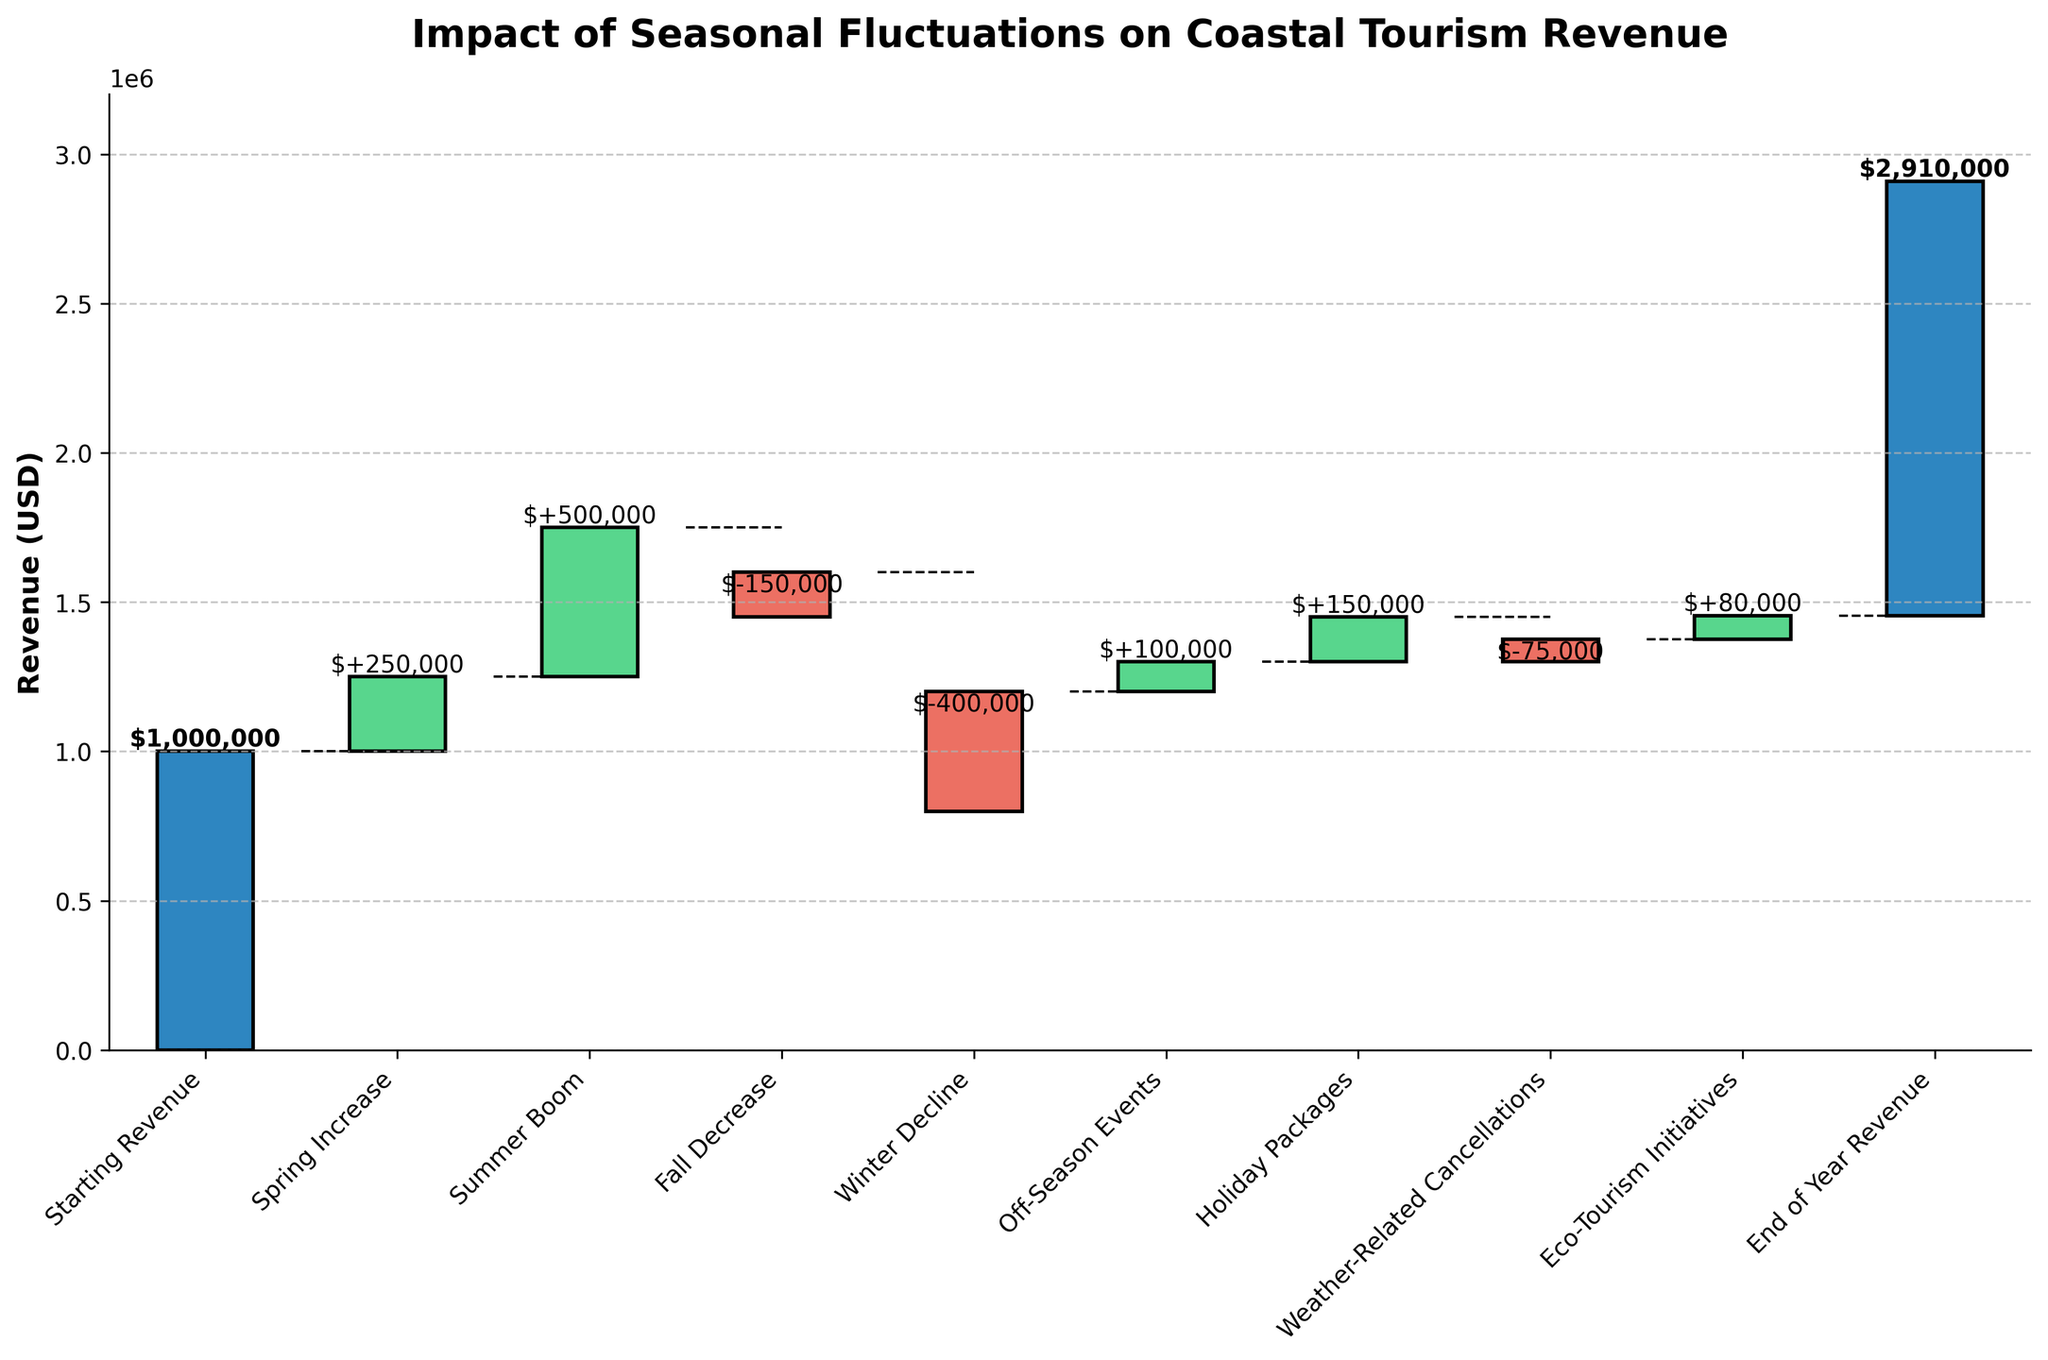How many categories are shown in the waterfall chart? There are 10 categories listed on the x-axis starting from "Starting Revenue" to "End of Year Revenue".
Answer: 10 What is the title of the chart? The title is displayed at the top of the chart.
Answer: Impact of Seasonal Fluctuations on Coastal Tourism Revenue How much does the revenue decrease in the fall? The "Fall Decrease" bar shows a downward movement of $150,000.
Answer: $150,000 What was the revenue at the end of the year? The "End of Year Revenue" is marked at the end of the chart, showing $1,455,000.
Answer: $1,455,000 Which season contributed the largest revenue increase? The "Summer Boom" bar has the highest value in the positive direction, indicating a contribution of $500,000.
Answer: Summer Boom What is the combined impact of Fall Decrease and Winter Decline? The "Fall Decrease" and "Winter Decline" bars show -$150,000 and -$400,000, respectively. Adding them up gives -$550,000.
Answer: -$550,000 How does off-season events impact the revenue? The "Off-Season Events" bar shows an upward movement, indicating an increase of $100,000.
Answer: $100,000 Which category represents the smallest impact on revenue, and what is that value? The "Weather-Related Cancellations" category shows the smallest impact with a -$75,000 change.
Answer: Weather-Related Cancellations, -$75,000 By how much does the holiday packages increase the revenue? The "Holiday Packages" bar indicates an increase of $150,000.
Answer: $150,000 What is the net impact of the positive influences (spring increase, summer boom, off-season events, holiday packages, eco-tourism initiatives) on revenue? Sum the positive impacts: $250,000 (Spring) + $500,000 (Summer) + $100,000 (Off-Season) + $150,000 (Holiday) + $80,000 (Eco-Tourism) = $1,080,000.
Answer: $1,080,000 